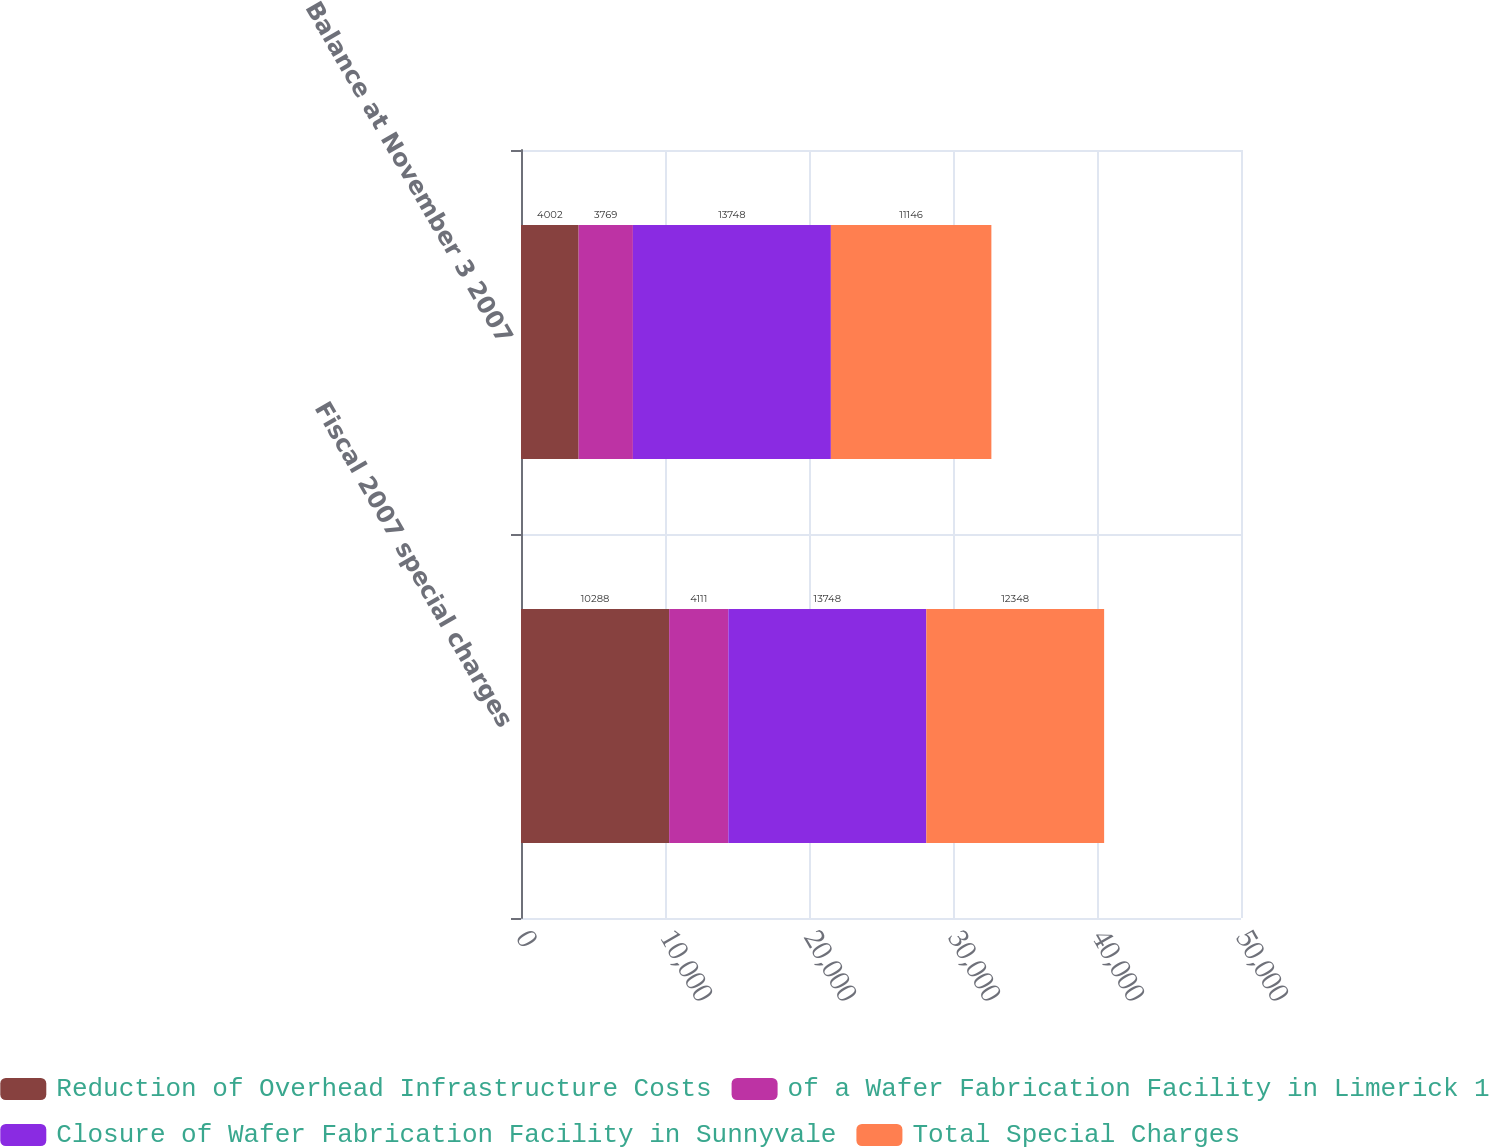Convert chart. <chart><loc_0><loc_0><loc_500><loc_500><stacked_bar_chart><ecel><fcel>Fiscal 2007 special charges<fcel>Balance at November 3 2007<nl><fcel>Reduction of Overhead Infrastructure Costs<fcel>10288<fcel>4002<nl><fcel>of a Wafer Fabrication Facility in Limerick 1<fcel>4111<fcel>3769<nl><fcel>Closure of Wafer Fabrication Facility in Sunnyvale<fcel>13748<fcel>13748<nl><fcel>Total Special Charges<fcel>12348<fcel>11146<nl></chart> 